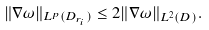<formula> <loc_0><loc_0><loc_500><loc_500>\| \nabla \omega \| _ { L ^ { p } ( D _ { r _ { i } } ) } \leq 2 \| \nabla \omega \| _ { L ^ { 2 } ( D ) } .</formula> 